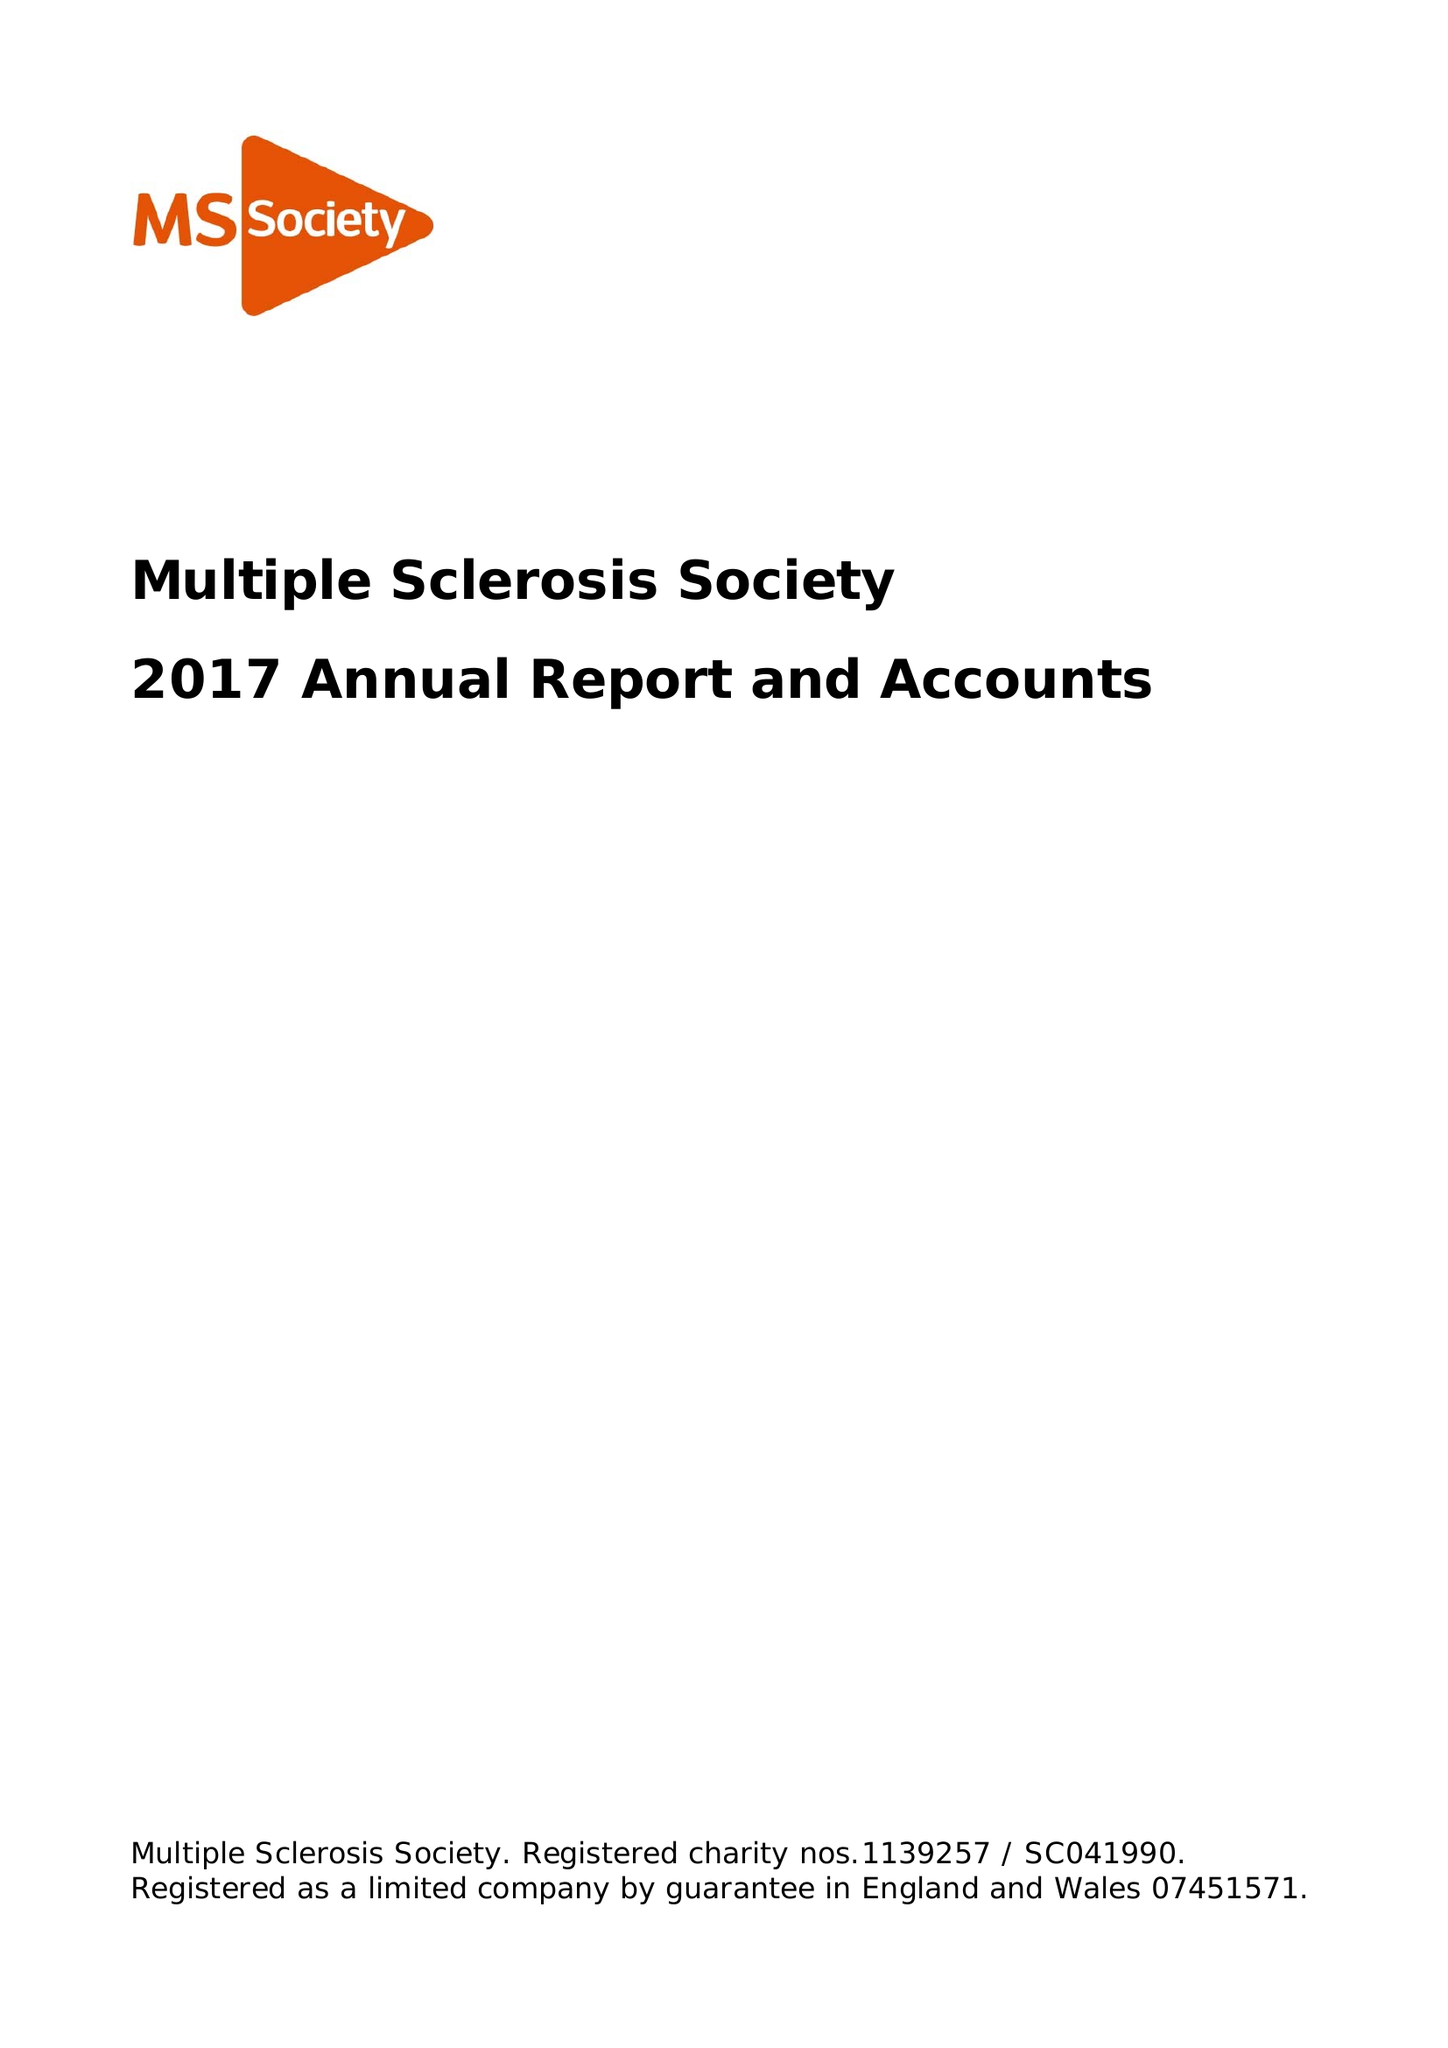What is the value for the report_date?
Answer the question using a single word or phrase. 2017-12-31 